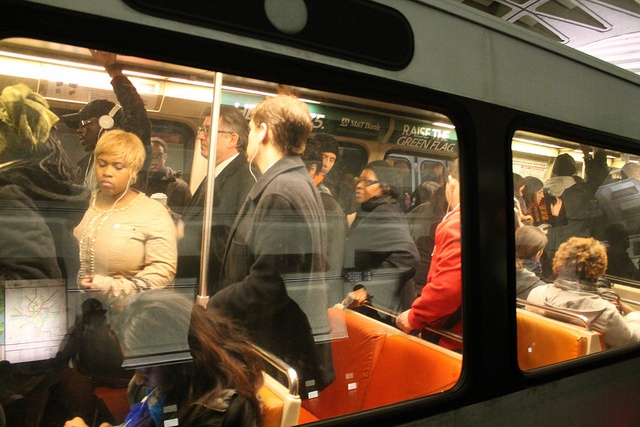Describe the objects in this image and their specific colors. I can see train in black, gray, maroon, and khaki tones, people in black, gray, and maroon tones, people in black, gray, and tan tones, people in black, khaki, tan, and gray tones, and people in black and gray tones in this image. 